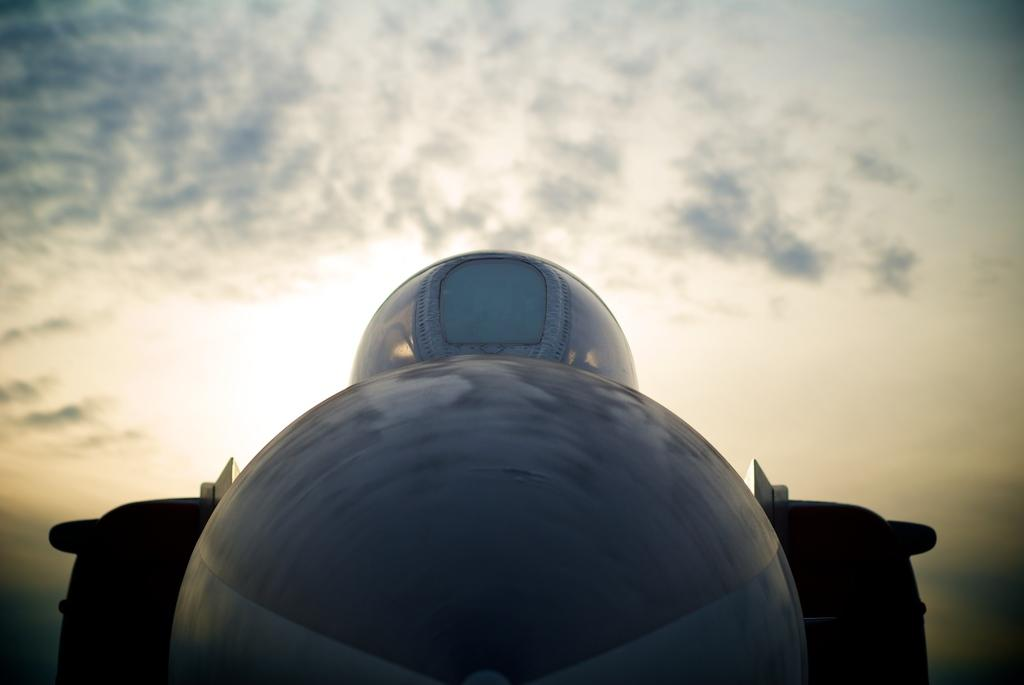What is the main subject in the foreground of the image? There is an object in the foreground that appears to be a vehicle. What can be seen in the background of the image? The sky is visible in the background of the image. Can you describe the sky in the image? The sky is full of clouds. How many donkeys are visible in the image? There are no donkeys present in the image. What level of difficulty is the wool challenge in the image? There is no wool or challenge present in the image. 